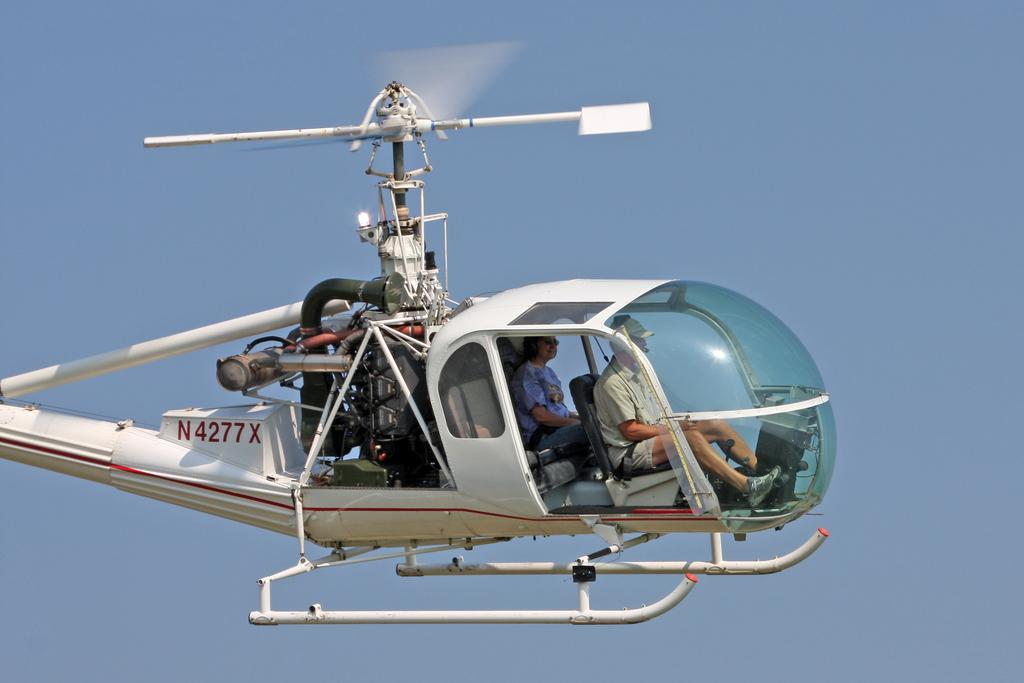<image>
Render a clear and concise summary of the photo. N4277 in red on a  white helicopter in the sky flying. 